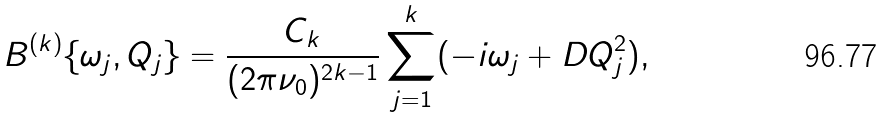Convert formula to latex. <formula><loc_0><loc_0><loc_500><loc_500>B ^ { ( k ) } \{ \omega _ { j } , Q _ { j } \} = \frac { C _ { k } } { ( 2 \pi \nu _ { 0 } ) ^ { 2 k - 1 } } \sum ^ { k } _ { j = 1 } ( - i \omega _ { j } + D Q ^ { 2 } _ { j } ) ,</formula> 